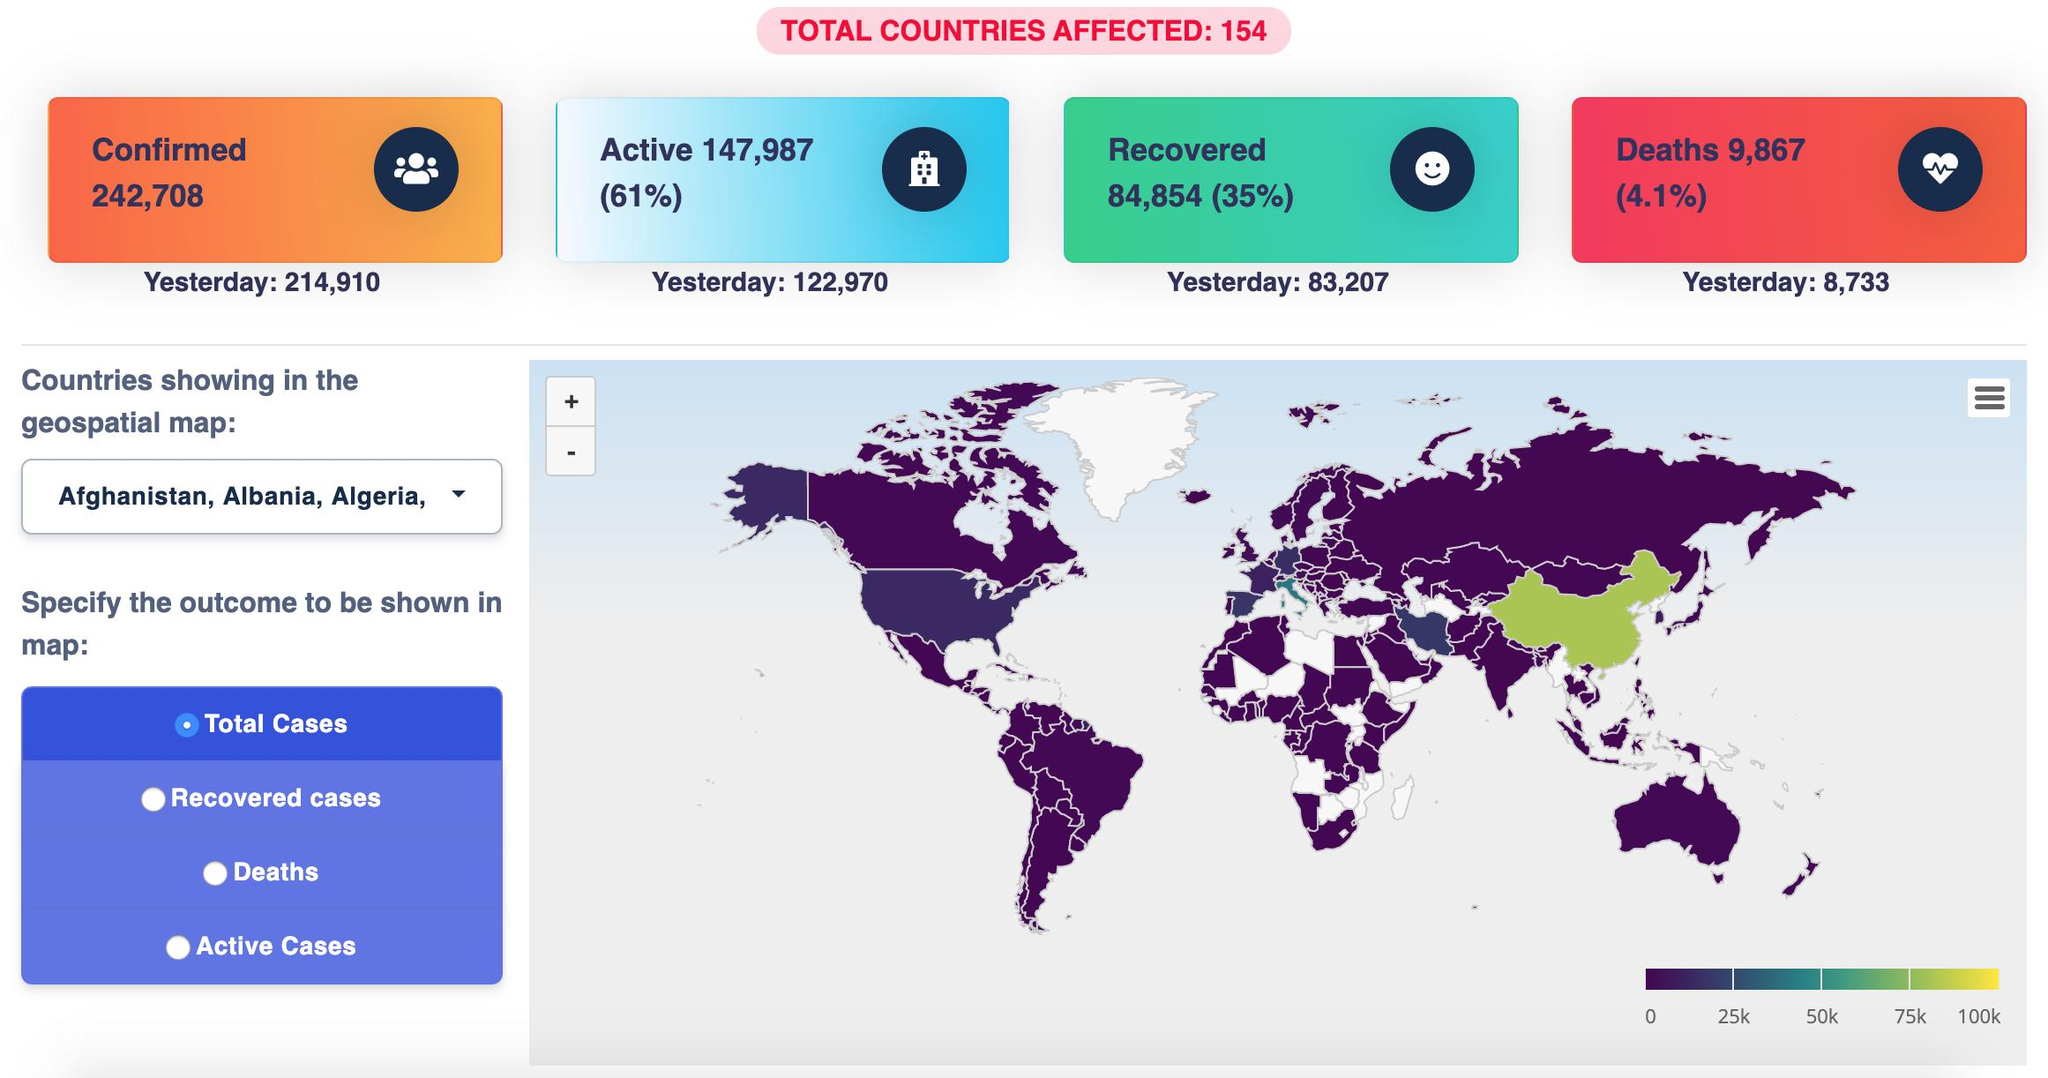Draw attention to some important aspects in this diagram. The total confirmed cases are 242,708. China is the country shown in green, while India is not shown in green. The death rate is 4.1%. The recovery rate is approximately 35%. Approximately 147,987 individuals have yet to be recovered. 